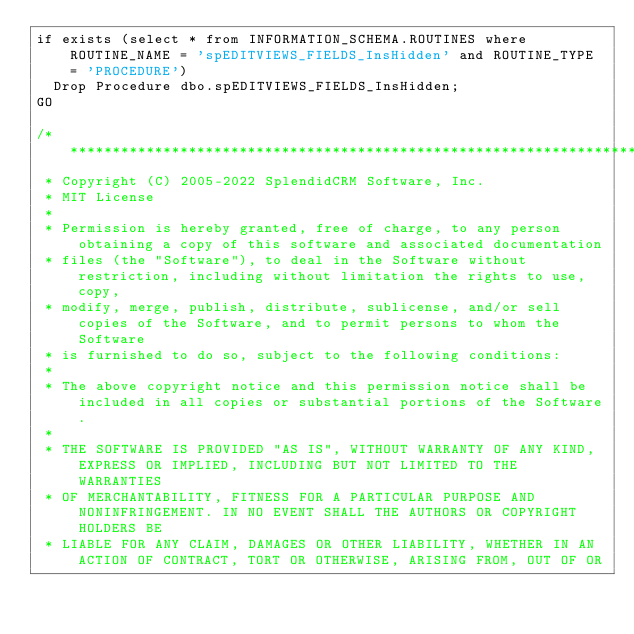Convert code to text. <code><loc_0><loc_0><loc_500><loc_500><_SQL_>if exists (select * from INFORMATION_SCHEMA.ROUTINES where ROUTINE_NAME = 'spEDITVIEWS_FIELDS_InsHidden' and ROUTINE_TYPE = 'PROCEDURE')
	Drop Procedure dbo.spEDITVIEWS_FIELDS_InsHidden;
GO

/**********************************************************************************************************************
 * Copyright (C) 2005-2022 SplendidCRM Software, Inc. 
 * MIT License
 * 
 * Permission is hereby granted, free of charge, to any person obtaining a copy of this software and associated documentation 
 * files (the "Software"), to deal in the Software without restriction, including without limitation the rights to use, copy, 
 * modify, merge, publish, distribute, sublicense, and/or sell copies of the Software, and to permit persons to whom the Software 
 * is furnished to do so, subject to the following conditions:
 * 
 * The above copyright notice and this permission notice shall be included in all copies or substantial portions of the Software.
 * 
 * THE SOFTWARE IS PROVIDED "AS IS", WITHOUT WARRANTY OF ANY KIND, EXPRESS OR IMPLIED, INCLUDING BUT NOT LIMITED TO THE WARRANTIES 
 * OF MERCHANTABILITY, FITNESS FOR A PARTICULAR PURPOSE AND NONINFRINGEMENT. IN NO EVENT SHALL THE AUTHORS OR COPYRIGHT HOLDERS BE 
 * LIABLE FOR ANY CLAIM, DAMAGES OR OTHER LIABILITY, WHETHER IN AN ACTION OF CONTRACT, TORT OR OTHERWISE, ARISING FROM, OUT OF OR </code> 